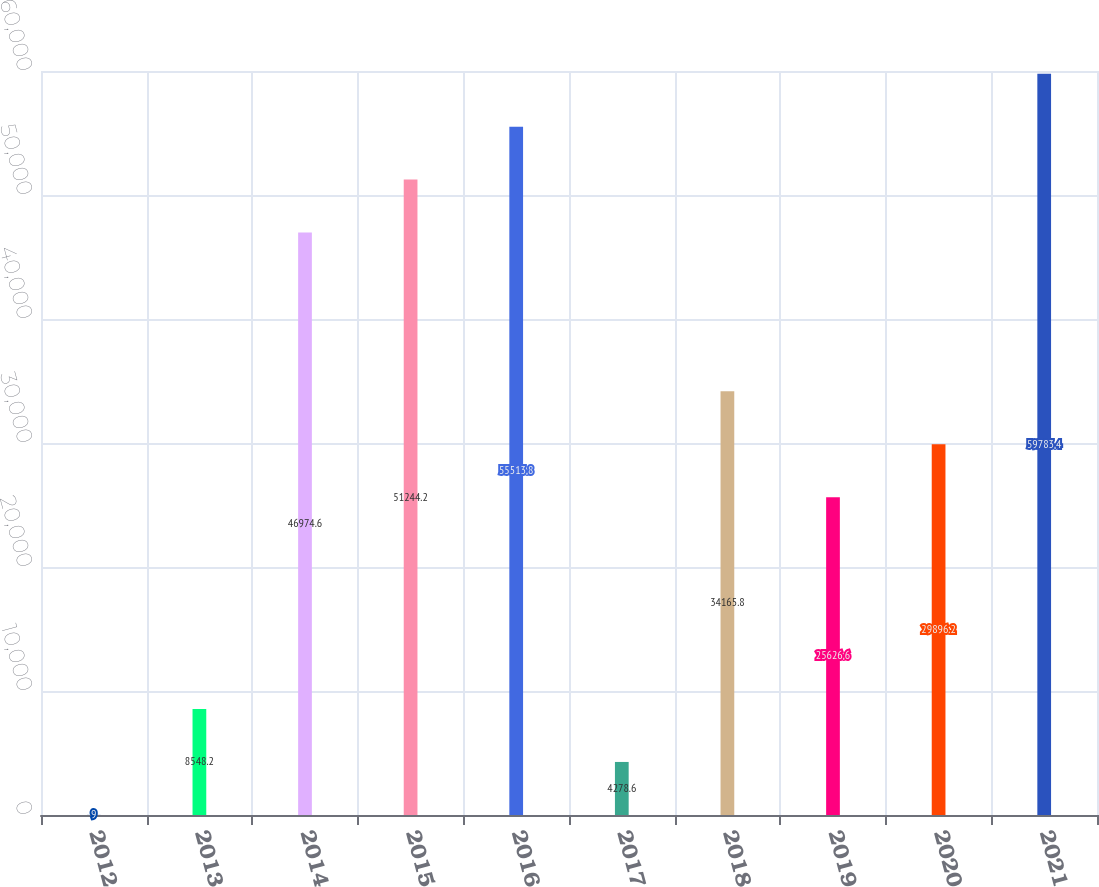Convert chart. <chart><loc_0><loc_0><loc_500><loc_500><bar_chart><fcel>2012<fcel>2013<fcel>2014<fcel>2015<fcel>2016<fcel>2017<fcel>2018<fcel>2019<fcel>2020<fcel>2021<nl><fcel>9<fcel>8548.2<fcel>46974.6<fcel>51244.2<fcel>55513.8<fcel>4278.6<fcel>34165.8<fcel>25626.6<fcel>29896.2<fcel>59783.4<nl></chart> 